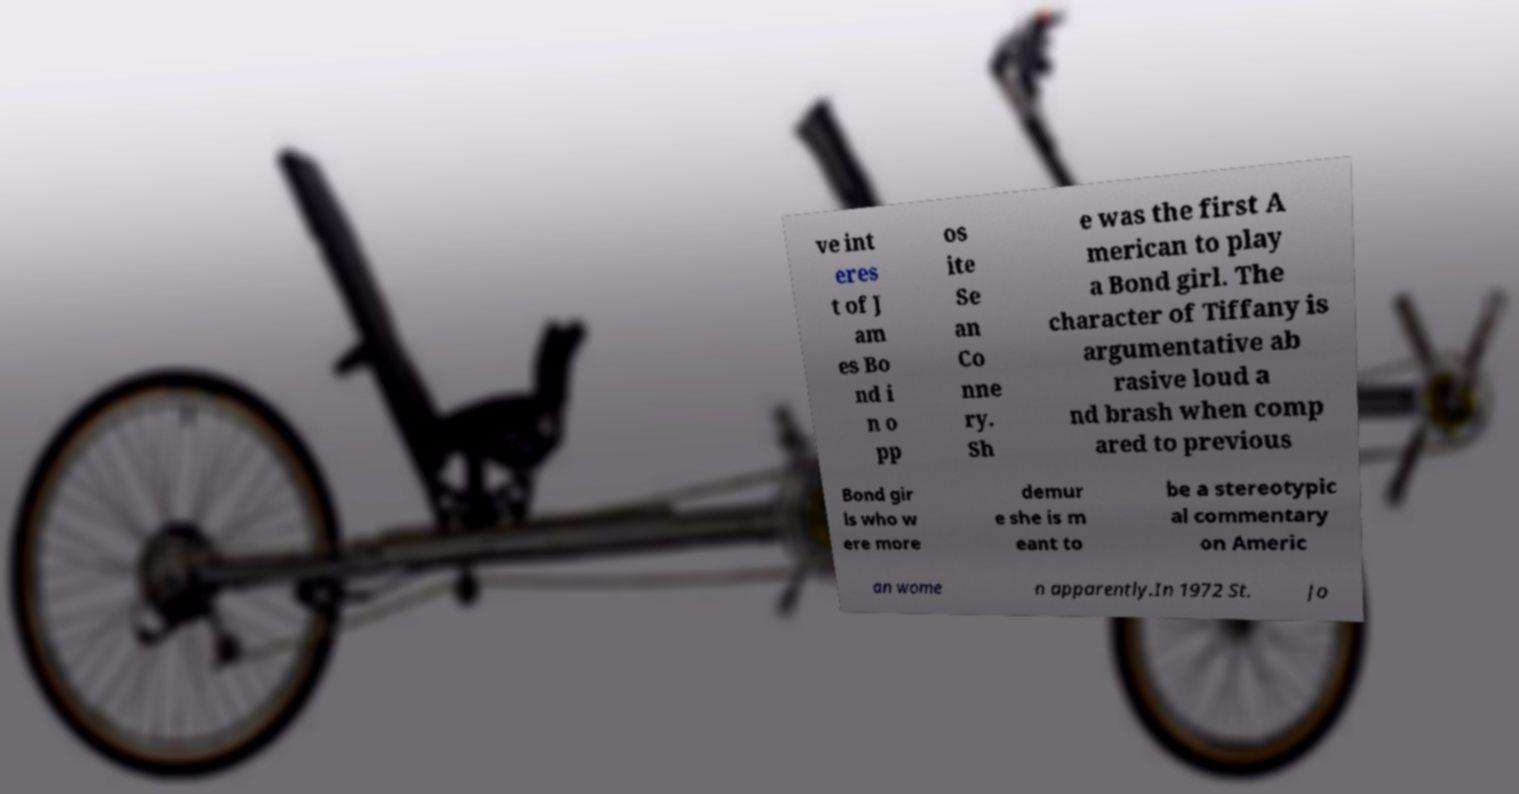Can you read and provide the text displayed in the image?This photo seems to have some interesting text. Can you extract and type it out for me? ve int eres t of J am es Bo nd i n o pp os ite Se an Co nne ry. Sh e was the first A merican to play a Bond girl. The character of Tiffany is argumentative ab rasive loud a nd brash when comp ared to previous Bond gir ls who w ere more demur e she is m eant to be a stereotypic al commentary on Americ an wome n apparently.In 1972 St. Jo 